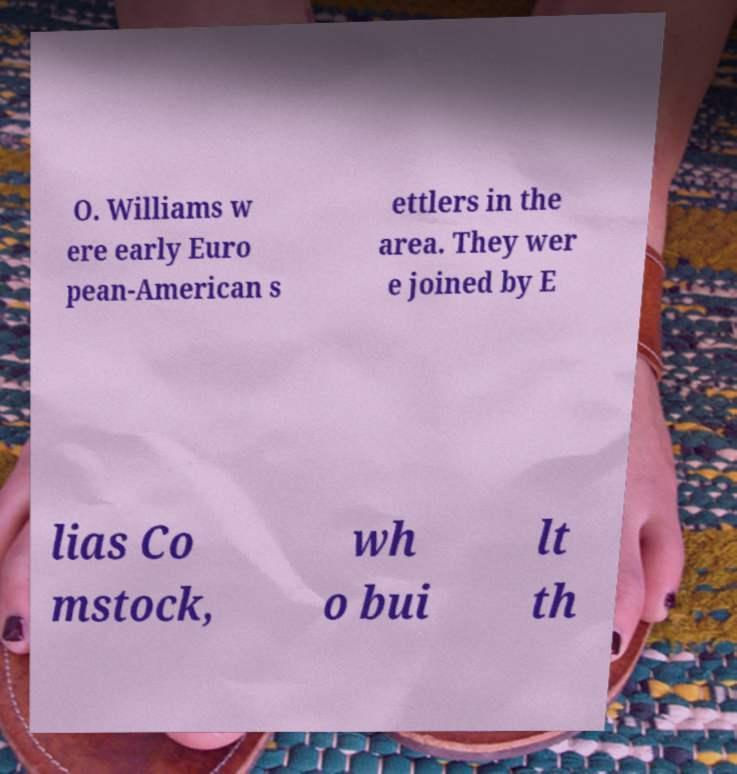I need the written content from this picture converted into text. Can you do that? O. Williams w ere early Euro pean-American s ettlers in the area. They wer e joined by E lias Co mstock, wh o bui lt th 